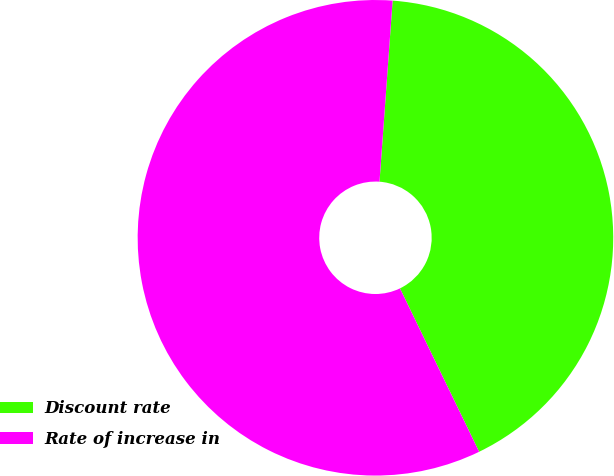Convert chart. <chart><loc_0><loc_0><loc_500><loc_500><pie_chart><fcel>Discount rate<fcel>Rate of increase in<nl><fcel>41.67%<fcel>58.33%<nl></chart> 